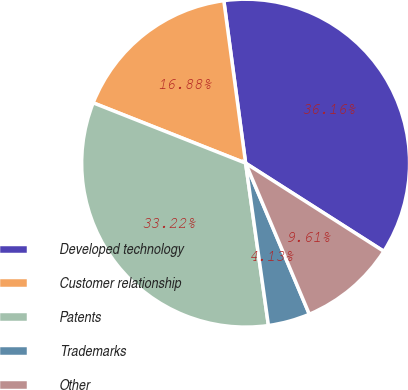Convert chart. <chart><loc_0><loc_0><loc_500><loc_500><pie_chart><fcel>Developed technology<fcel>Customer relationship<fcel>Patents<fcel>Trademarks<fcel>Other<nl><fcel>36.16%<fcel>16.88%<fcel>33.22%<fcel>4.13%<fcel>9.61%<nl></chart> 